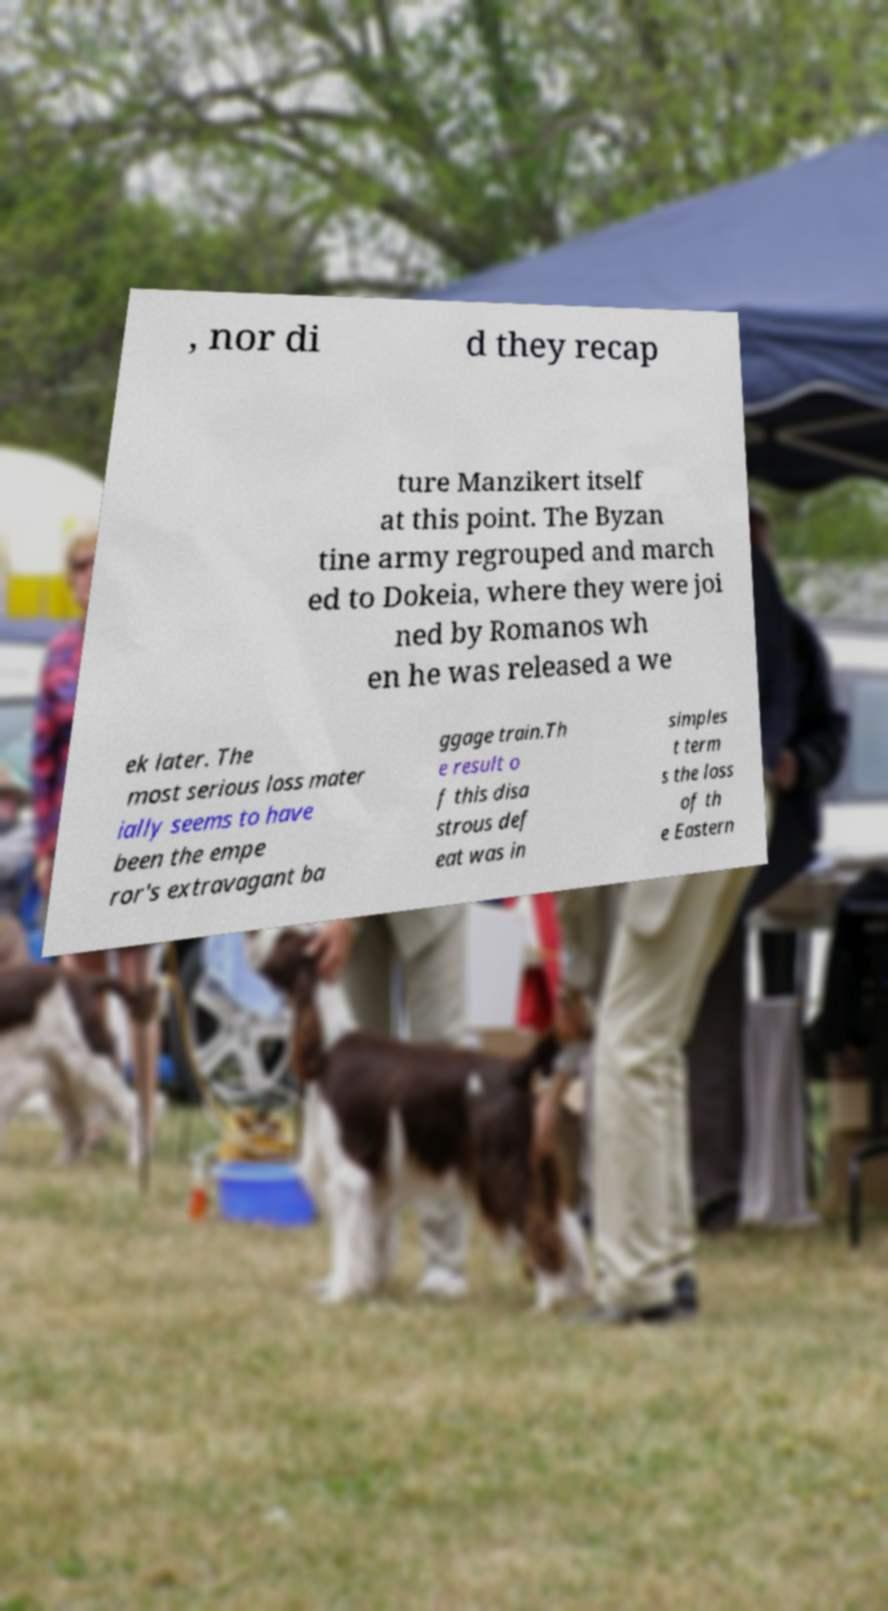What messages or text are displayed in this image? I need them in a readable, typed format. , nor di d they recap ture Manzikert itself at this point. The Byzan tine army regrouped and march ed to Dokeia, where they were joi ned by Romanos wh en he was released a we ek later. The most serious loss mater ially seems to have been the empe ror's extravagant ba ggage train.Th e result o f this disa strous def eat was in simples t term s the loss of th e Eastern 